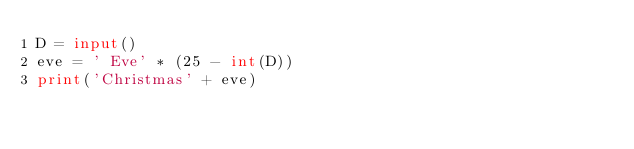Convert code to text. <code><loc_0><loc_0><loc_500><loc_500><_Python_>D = input()
eve = ' Eve' * (25 - int(D))
print('Christmas' + eve)</code> 